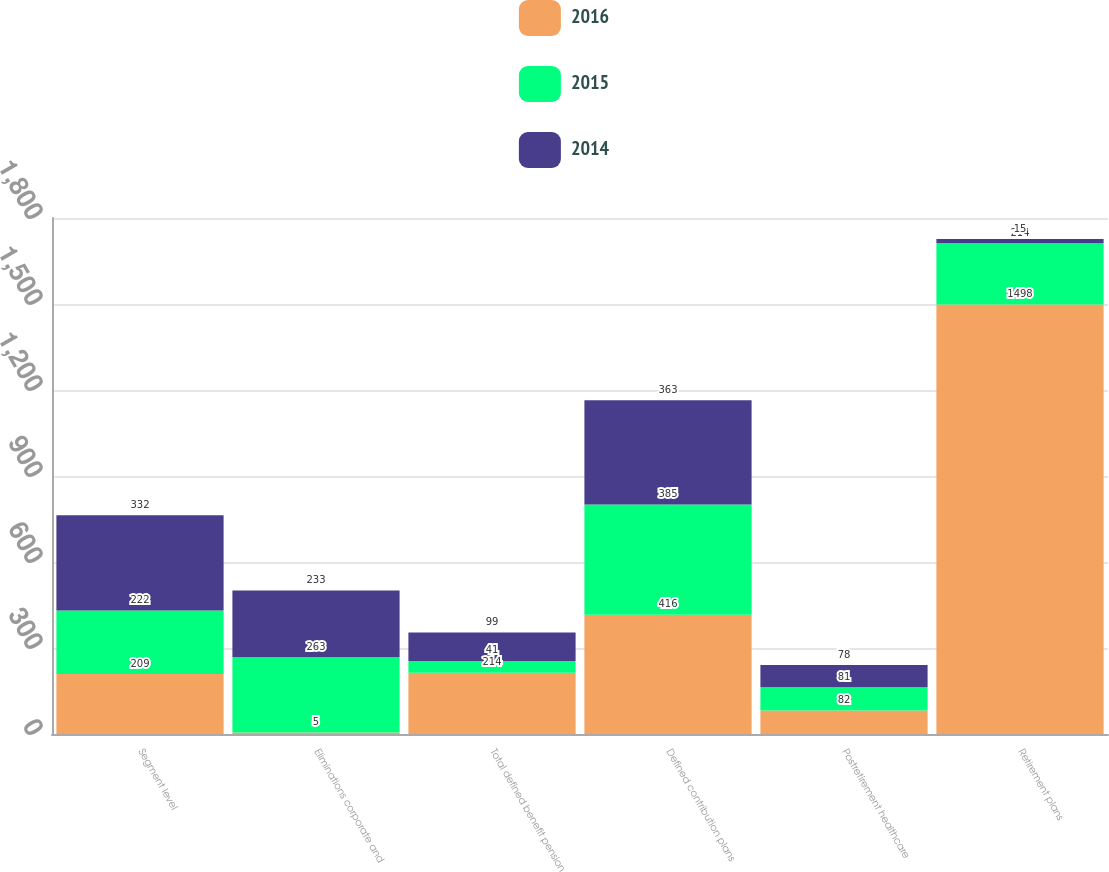Convert chart to OTSL. <chart><loc_0><loc_0><loc_500><loc_500><stacked_bar_chart><ecel><fcel>Segment level<fcel>Eliminations corporate and<fcel>Total defined benefit pension<fcel>Defined contribution plans<fcel>Postretirement healthcare<fcel>Retirement plans<nl><fcel>2016<fcel>209<fcel>5<fcel>214<fcel>416<fcel>82<fcel>1498<nl><fcel>2015<fcel>222<fcel>263<fcel>41<fcel>385<fcel>81<fcel>214<nl><fcel>2014<fcel>332<fcel>233<fcel>99<fcel>363<fcel>78<fcel>15<nl></chart> 